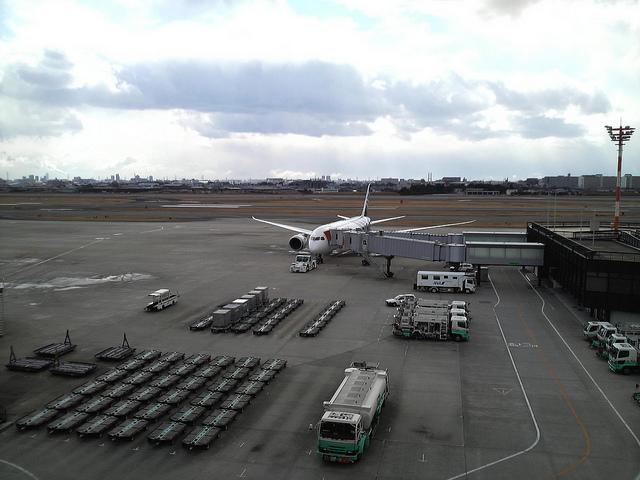Is the plane in the air?
Keep it brief. No. Is this a cloudy day?
Keep it brief. Yes. Is the plane in motion?
Keep it brief. No. 